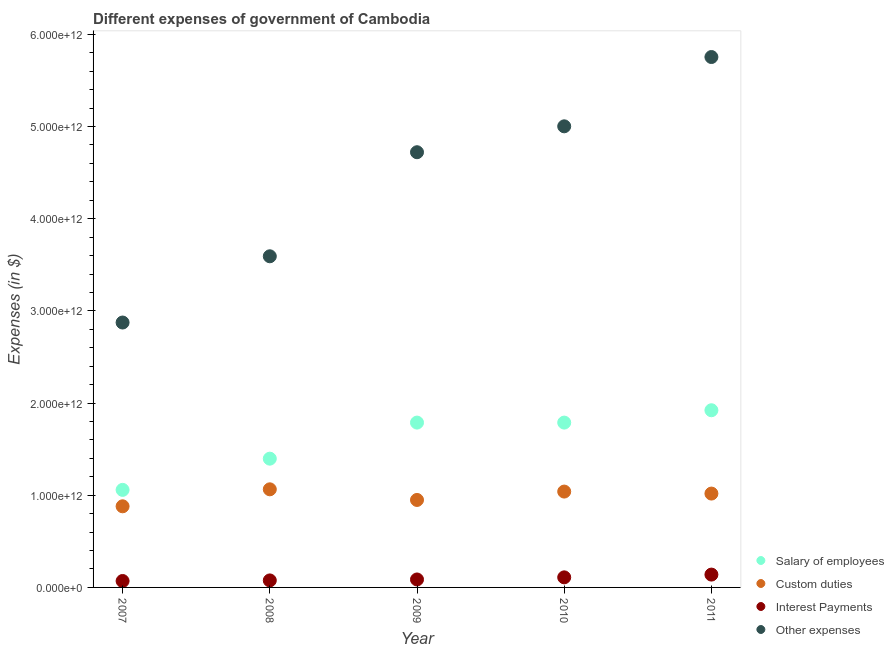How many different coloured dotlines are there?
Your answer should be compact. 4. Is the number of dotlines equal to the number of legend labels?
Keep it short and to the point. Yes. What is the amount spent on interest payments in 2011?
Your answer should be very brief. 1.39e+11. Across all years, what is the maximum amount spent on other expenses?
Your answer should be compact. 5.75e+12. Across all years, what is the minimum amount spent on other expenses?
Your answer should be very brief. 2.87e+12. In which year was the amount spent on salary of employees minimum?
Ensure brevity in your answer.  2007. What is the total amount spent on custom duties in the graph?
Your answer should be compact. 4.95e+12. What is the difference between the amount spent on interest payments in 2009 and that in 2010?
Provide a short and direct response. -2.30e+1. What is the difference between the amount spent on interest payments in 2011 and the amount spent on salary of employees in 2009?
Offer a terse response. -1.65e+12. What is the average amount spent on salary of employees per year?
Keep it short and to the point. 1.59e+12. In the year 2009, what is the difference between the amount spent on other expenses and amount spent on custom duties?
Offer a very short reply. 3.77e+12. In how many years, is the amount spent on custom duties greater than 5200000000000 $?
Offer a terse response. 0. What is the ratio of the amount spent on interest payments in 2007 to that in 2008?
Ensure brevity in your answer.  0.92. Is the amount spent on interest payments in 2007 less than that in 2011?
Keep it short and to the point. Yes. Is the difference between the amount spent on salary of employees in 2008 and 2009 greater than the difference between the amount spent on custom duties in 2008 and 2009?
Make the answer very short. No. What is the difference between the highest and the second highest amount spent on other expenses?
Your response must be concise. 7.52e+11. What is the difference between the highest and the lowest amount spent on interest payments?
Provide a succinct answer. 6.95e+1. In how many years, is the amount spent on other expenses greater than the average amount spent on other expenses taken over all years?
Your answer should be very brief. 3. Is the sum of the amount spent on salary of employees in 2007 and 2011 greater than the maximum amount spent on custom duties across all years?
Make the answer very short. Yes. Is it the case that in every year, the sum of the amount spent on salary of employees and amount spent on other expenses is greater than the sum of amount spent on custom duties and amount spent on interest payments?
Offer a terse response. Yes. Does the amount spent on other expenses monotonically increase over the years?
Your response must be concise. Yes. Is the amount spent on salary of employees strictly greater than the amount spent on other expenses over the years?
Make the answer very short. No. Is the amount spent on other expenses strictly less than the amount spent on salary of employees over the years?
Give a very brief answer. No. How many dotlines are there?
Give a very brief answer. 4. How many years are there in the graph?
Provide a short and direct response. 5. What is the difference between two consecutive major ticks on the Y-axis?
Your response must be concise. 1.00e+12. Are the values on the major ticks of Y-axis written in scientific E-notation?
Keep it short and to the point. Yes. Does the graph contain any zero values?
Make the answer very short. No. Where does the legend appear in the graph?
Your response must be concise. Bottom right. How many legend labels are there?
Give a very brief answer. 4. How are the legend labels stacked?
Your response must be concise. Vertical. What is the title of the graph?
Keep it short and to the point. Different expenses of government of Cambodia. Does "Manufacturing" appear as one of the legend labels in the graph?
Provide a short and direct response. No. What is the label or title of the X-axis?
Offer a very short reply. Year. What is the label or title of the Y-axis?
Offer a very short reply. Expenses (in $). What is the Expenses (in $) in Salary of employees in 2007?
Your answer should be compact. 1.06e+12. What is the Expenses (in $) of Custom duties in 2007?
Provide a succinct answer. 8.80e+11. What is the Expenses (in $) in Interest Payments in 2007?
Keep it short and to the point. 6.97e+1. What is the Expenses (in $) of Other expenses in 2007?
Ensure brevity in your answer.  2.87e+12. What is the Expenses (in $) of Salary of employees in 2008?
Give a very brief answer. 1.40e+12. What is the Expenses (in $) of Custom duties in 2008?
Ensure brevity in your answer.  1.06e+12. What is the Expenses (in $) in Interest Payments in 2008?
Offer a terse response. 7.61e+1. What is the Expenses (in $) in Other expenses in 2008?
Provide a succinct answer. 3.59e+12. What is the Expenses (in $) of Salary of employees in 2009?
Make the answer very short. 1.79e+12. What is the Expenses (in $) in Custom duties in 2009?
Your answer should be very brief. 9.49e+11. What is the Expenses (in $) of Interest Payments in 2009?
Your answer should be very brief. 8.63e+1. What is the Expenses (in $) of Other expenses in 2009?
Your answer should be compact. 4.72e+12. What is the Expenses (in $) of Salary of employees in 2010?
Provide a succinct answer. 1.79e+12. What is the Expenses (in $) in Custom duties in 2010?
Your response must be concise. 1.04e+12. What is the Expenses (in $) in Interest Payments in 2010?
Offer a terse response. 1.09e+11. What is the Expenses (in $) in Other expenses in 2010?
Provide a short and direct response. 5.00e+12. What is the Expenses (in $) in Salary of employees in 2011?
Offer a terse response. 1.92e+12. What is the Expenses (in $) in Custom duties in 2011?
Provide a succinct answer. 1.02e+12. What is the Expenses (in $) of Interest Payments in 2011?
Your answer should be very brief. 1.39e+11. What is the Expenses (in $) in Other expenses in 2011?
Offer a terse response. 5.75e+12. Across all years, what is the maximum Expenses (in $) in Salary of employees?
Offer a very short reply. 1.92e+12. Across all years, what is the maximum Expenses (in $) in Custom duties?
Your answer should be very brief. 1.06e+12. Across all years, what is the maximum Expenses (in $) in Interest Payments?
Offer a terse response. 1.39e+11. Across all years, what is the maximum Expenses (in $) of Other expenses?
Your answer should be very brief. 5.75e+12. Across all years, what is the minimum Expenses (in $) of Salary of employees?
Make the answer very short. 1.06e+12. Across all years, what is the minimum Expenses (in $) of Custom duties?
Give a very brief answer. 8.80e+11. Across all years, what is the minimum Expenses (in $) of Interest Payments?
Your answer should be compact. 6.97e+1. Across all years, what is the minimum Expenses (in $) in Other expenses?
Your answer should be very brief. 2.87e+12. What is the total Expenses (in $) in Salary of employees in the graph?
Your answer should be very brief. 7.95e+12. What is the total Expenses (in $) of Custom duties in the graph?
Keep it short and to the point. 4.95e+12. What is the total Expenses (in $) of Interest Payments in the graph?
Provide a succinct answer. 4.81e+11. What is the total Expenses (in $) in Other expenses in the graph?
Keep it short and to the point. 2.19e+13. What is the difference between the Expenses (in $) in Salary of employees in 2007 and that in 2008?
Provide a short and direct response. -3.39e+11. What is the difference between the Expenses (in $) of Custom duties in 2007 and that in 2008?
Provide a succinct answer. -1.84e+11. What is the difference between the Expenses (in $) of Interest Payments in 2007 and that in 2008?
Your response must be concise. -6.34e+09. What is the difference between the Expenses (in $) of Other expenses in 2007 and that in 2008?
Ensure brevity in your answer.  -7.19e+11. What is the difference between the Expenses (in $) in Salary of employees in 2007 and that in 2009?
Your answer should be very brief. -7.30e+11. What is the difference between the Expenses (in $) of Custom duties in 2007 and that in 2009?
Offer a very short reply. -6.90e+1. What is the difference between the Expenses (in $) of Interest Payments in 2007 and that in 2009?
Offer a very short reply. -1.66e+1. What is the difference between the Expenses (in $) in Other expenses in 2007 and that in 2009?
Give a very brief answer. -1.85e+12. What is the difference between the Expenses (in $) of Salary of employees in 2007 and that in 2010?
Offer a terse response. -7.30e+11. What is the difference between the Expenses (in $) of Custom duties in 2007 and that in 2010?
Make the answer very short. -1.60e+11. What is the difference between the Expenses (in $) in Interest Payments in 2007 and that in 2010?
Offer a very short reply. -3.96e+1. What is the difference between the Expenses (in $) in Other expenses in 2007 and that in 2010?
Your answer should be very brief. -2.13e+12. What is the difference between the Expenses (in $) in Salary of employees in 2007 and that in 2011?
Give a very brief answer. -8.64e+11. What is the difference between the Expenses (in $) of Custom duties in 2007 and that in 2011?
Keep it short and to the point. -1.38e+11. What is the difference between the Expenses (in $) of Interest Payments in 2007 and that in 2011?
Your answer should be very brief. -6.95e+1. What is the difference between the Expenses (in $) of Other expenses in 2007 and that in 2011?
Make the answer very short. -2.88e+12. What is the difference between the Expenses (in $) in Salary of employees in 2008 and that in 2009?
Keep it short and to the point. -3.91e+11. What is the difference between the Expenses (in $) of Custom duties in 2008 and that in 2009?
Provide a short and direct response. 1.15e+11. What is the difference between the Expenses (in $) in Interest Payments in 2008 and that in 2009?
Your answer should be compact. -1.02e+1. What is the difference between the Expenses (in $) in Other expenses in 2008 and that in 2009?
Provide a succinct answer. -1.13e+12. What is the difference between the Expenses (in $) in Salary of employees in 2008 and that in 2010?
Ensure brevity in your answer.  -3.91e+11. What is the difference between the Expenses (in $) of Custom duties in 2008 and that in 2010?
Ensure brevity in your answer.  2.45e+1. What is the difference between the Expenses (in $) of Interest Payments in 2008 and that in 2010?
Give a very brief answer. -3.32e+1. What is the difference between the Expenses (in $) of Other expenses in 2008 and that in 2010?
Give a very brief answer. -1.41e+12. What is the difference between the Expenses (in $) in Salary of employees in 2008 and that in 2011?
Ensure brevity in your answer.  -5.25e+11. What is the difference between the Expenses (in $) of Custom duties in 2008 and that in 2011?
Make the answer very short. 4.62e+1. What is the difference between the Expenses (in $) of Interest Payments in 2008 and that in 2011?
Give a very brief answer. -6.32e+1. What is the difference between the Expenses (in $) in Other expenses in 2008 and that in 2011?
Offer a very short reply. -2.16e+12. What is the difference between the Expenses (in $) in Salary of employees in 2009 and that in 2010?
Provide a succinct answer. 6.24e+06. What is the difference between the Expenses (in $) in Custom duties in 2009 and that in 2010?
Your answer should be compact. -9.09e+1. What is the difference between the Expenses (in $) of Interest Payments in 2009 and that in 2010?
Your answer should be very brief. -2.30e+1. What is the difference between the Expenses (in $) of Other expenses in 2009 and that in 2010?
Provide a short and direct response. -2.81e+11. What is the difference between the Expenses (in $) in Salary of employees in 2009 and that in 2011?
Make the answer very short. -1.34e+11. What is the difference between the Expenses (in $) in Custom duties in 2009 and that in 2011?
Ensure brevity in your answer.  -6.92e+1. What is the difference between the Expenses (in $) of Interest Payments in 2009 and that in 2011?
Give a very brief answer. -5.29e+1. What is the difference between the Expenses (in $) in Other expenses in 2009 and that in 2011?
Keep it short and to the point. -1.03e+12. What is the difference between the Expenses (in $) in Salary of employees in 2010 and that in 2011?
Your answer should be compact. -1.34e+11. What is the difference between the Expenses (in $) in Custom duties in 2010 and that in 2011?
Your answer should be compact. 2.17e+1. What is the difference between the Expenses (in $) in Interest Payments in 2010 and that in 2011?
Ensure brevity in your answer.  -2.99e+1. What is the difference between the Expenses (in $) of Other expenses in 2010 and that in 2011?
Make the answer very short. -7.52e+11. What is the difference between the Expenses (in $) in Salary of employees in 2007 and the Expenses (in $) in Custom duties in 2008?
Offer a terse response. -6.22e+09. What is the difference between the Expenses (in $) of Salary of employees in 2007 and the Expenses (in $) of Interest Payments in 2008?
Make the answer very short. 9.82e+11. What is the difference between the Expenses (in $) in Salary of employees in 2007 and the Expenses (in $) in Other expenses in 2008?
Ensure brevity in your answer.  -2.53e+12. What is the difference between the Expenses (in $) of Custom duties in 2007 and the Expenses (in $) of Interest Payments in 2008?
Keep it short and to the point. 8.04e+11. What is the difference between the Expenses (in $) in Custom duties in 2007 and the Expenses (in $) in Other expenses in 2008?
Your answer should be very brief. -2.71e+12. What is the difference between the Expenses (in $) of Interest Payments in 2007 and the Expenses (in $) of Other expenses in 2008?
Provide a short and direct response. -3.52e+12. What is the difference between the Expenses (in $) in Salary of employees in 2007 and the Expenses (in $) in Custom duties in 2009?
Provide a short and direct response. 1.09e+11. What is the difference between the Expenses (in $) in Salary of employees in 2007 and the Expenses (in $) in Interest Payments in 2009?
Your response must be concise. 9.72e+11. What is the difference between the Expenses (in $) of Salary of employees in 2007 and the Expenses (in $) of Other expenses in 2009?
Your answer should be very brief. -3.66e+12. What is the difference between the Expenses (in $) in Custom duties in 2007 and the Expenses (in $) in Interest Payments in 2009?
Provide a short and direct response. 7.94e+11. What is the difference between the Expenses (in $) of Custom duties in 2007 and the Expenses (in $) of Other expenses in 2009?
Provide a short and direct response. -3.84e+12. What is the difference between the Expenses (in $) in Interest Payments in 2007 and the Expenses (in $) in Other expenses in 2009?
Your answer should be very brief. -4.65e+12. What is the difference between the Expenses (in $) in Salary of employees in 2007 and the Expenses (in $) in Custom duties in 2010?
Provide a succinct answer. 1.83e+1. What is the difference between the Expenses (in $) of Salary of employees in 2007 and the Expenses (in $) of Interest Payments in 2010?
Make the answer very short. 9.49e+11. What is the difference between the Expenses (in $) in Salary of employees in 2007 and the Expenses (in $) in Other expenses in 2010?
Your answer should be compact. -3.94e+12. What is the difference between the Expenses (in $) of Custom duties in 2007 and the Expenses (in $) of Interest Payments in 2010?
Offer a terse response. 7.71e+11. What is the difference between the Expenses (in $) in Custom duties in 2007 and the Expenses (in $) in Other expenses in 2010?
Offer a terse response. -4.12e+12. What is the difference between the Expenses (in $) of Interest Payments in 2007 and the Expenses (in $) of Other expenses in 2010?
Ensure brevity in your answer.  -4.93e+12. What is the difference between the Expenses (in $) of Salary of employees in 2007 and the Expenses (in $) of Custom duties in 2011?
Ensure brevity in your answer.  4.00e+1. What is the difference between the Expenses (in $) of Salary of employees in 2007 and the Expenses (in $) of Interest Payments in 2011?
Keep it short and to the point. 9.19e+11. What is the difference between the Expenses (in $) in Salary of employees in 2007 and the Expenses (in $) in Other expenses in 2011?
Offer a terse response. -4.70e+12. What is the difference between the Expenses (in $) of Custom duties in 2007 and the Expenses (in $) of Interest Payments in 2011?
Ensure brevity in your answer.  7.41e+11. What is the difference between the Expenses (in $) of Custom duties in 2007 and the Expenses (in $) of Other expenses in 2011?
Provide a short and direct response. -4.87e+12. What is the difference between the Expenses (in $) of Interest Payments in 2007 and the Expenses (in $) of Other expenses in 2011?
Provide a succinct answer. -5.68e+12. What is the difference between the Expenses (in $) of Salary of employees in 2008 and the Expenses (in $) of Custom duties in 2009?
Your response must be concise. 4.48e+11. What is the difference between the Expenses (in $) of Salary of employees in 2008 and the Expenses (in $) of Interest Payments in 2009?
Your answer should be compact. 1.31e+12. What is the difference between the Expenses (in $) in Salary of employees in 2008 and the Expenses (in $) in Other expenses in 2009?
Your response must be concise. -3.32e+12. What is the difference between the Expenses (in $) of Custom duties in 2008 and the Expenses (in $) of Interest Payments in 2009?
Your response must be concise. 9.78e+11. What is the difference between the Expenses (in $) of Custom duties in 2008 and the Expenses (in $) of Other expenses in 2009?
Ensure brevity in your answer.  -3.66e+12. What is the difference between the Expenses (in $) in Interest Payments in 2008 and the Expenses (in $) in Other expenses in 2009?
Offer a very short reply. -4.65e+12. What is the difference between the Expenses (in $) in Salary of employees in 2008 and the Expenses (in $) in Custom duties in 2010?
Keep it short and to the point. 3.57e+11. What is the difference between the Expenses (in $) in Salary of employees in 2008 and the Expenses (in $) in Interest Payments in 2010?
Offer a very short reply. 1.29e+12. What is the difference between the Expenses (in $) in Salary of employees in 2008 and the Expenses (in $) in Other expenses in 2010?
Provide a short and direct response. -3.61e+12. What is the difference between the Expenses (in $) in Custom duties in 2008 and the Expenses (in $) in Interest Payments in 2010?
Make the answer very short. 9.55e+11. What is the difference between the Expenses (in $) in Custom duties in 2008 and the Expenses (in $) in Other expenses in 2010?
Your response must be concise. -3.94e+12. What is the difference between the Expenses (in $) in Interest Payments in 2008 and the Expenses (in $) in Other expenses in 2010?
Provide a short and direct response. -4.93e+12. What is the difference between the Expenses (in $) of Salary of employees in 2008 and the Expenses (in $) of Custom duties in 2011?
Provide a succinct answer. 3.79e+11. What is the difference between the Expenses (in $) in Salary of employees in 2008 and the Expenses (in $) in Interest Payments in 2011?
Your answer should be compact. 1.26e+12. What is the difference between the Expenses (in $) in Salary of employees in 2008 and the Expenses (in $) in Other expenses in 2011?
Offer a terse response. -4.36e+12. What is the difference between the Expenses (in $) of Custom duties in 2008 and the Expenses (in $) of Interest Payments in 2011?
Offer a terse response. 9.25e+11. What is the difference between the Expenses (in $) of Custom duties in 2008 and the Expenses (in $) of Other expenses in 2011?
Provide a succinct answer. -4.69e+12. What is the difference between the Expenses (in $) of Interest Payments in 2008 and the Expenses (in $) of Other expenses in 2011?
Provide a succinct answer. -5.68e+12. What is the difference between the Expenses (in $) in Salary of employees in 2009 and the Expenses (in $) in Custom duties in 2010?
Your answer should be very brief. 7.48e+11. What is the difference between the Expenses (in $) of Salary of employees in 2009 and the Expenses (in $) of Interest Payments in 2010?
Give a very brief answer. 1.68e+12. What is the difference between the Expenses (in $) in Salary of employees in 2009 and the Expenses (in $) in Other expenses in 2010?
Give a very brief answer. -3.21e+12. What is the difference between the Expenses (in $) in Custom duties in 2009 and the Expenses (in $) in Interest Payments in 2010?
Keep it short and to the point. 8.40e+11. What is the difference between the Expenses (in $) in Custom duties in 2009 and the Expenses (in $) in Other expenses in 2010?
Ensure brevity in your answer.  -4.05e+12. What is the difference between the Expenses (in $) in Interest Payments in 2009 and the Expenses (in $) in Other expenses in 2010?
Make the answer very short. -4.92e+12. What is the difference between the Expenses (in $) in Salary of employees in 2009 and the Expenses (in $) in Custom duties in 2011?
Offer a terse response. 7.70e+11. What is the difference between the Expenses (in $) in Salary of employees in 2009 and the Expenses (in $) in Interest Payments in 2011?
Offer a terse response. 1.65e+12. What is the difference between the Expenses (in $) of Salary of employees in 2009 and the Expenses (in $) of Other expenses in 2011?
Make the answer very short. -3.97e+12. What is the difference between the Expenses (in $) of Custom duties in 2009 and the Expenses (in $) of Interest Payments in 2011?
Offer a very short reply. 8.10e+11. What is the difference between the Expenses (in $) of Custom duties in 2009 and the Expenses (in $) of Other expenses in 2011?
Your response must be concise. -4.81e+12. What is the difference between the Expenses (in $) of Interest Payments in 2009 and the Expenses (in $) of Other expenses in 2011?
Your response must be concise. -5.67e+12. What is the difference between the Expenses (in $) in Salary of employees in 2010 and the Expenses (in $) in Custom duties in 2011?
Offer a very short reply. 7.70e+11. What is the difference between the Expenses (in $) in Salary of employees in 2010 and the Expenses (in $) in Interest Payments in 2011?
Provide a succinct answer. 1.65e+12. What is the difference between the Expenses (in $) in Salary of employees in 2010 and the Expenses (in $) in Other expenses in 2011?
Provide a succinct answer. -3.97e+12. What is the difference between the Expenses (in $) in Custom duties in 2010 and the Expenses (in $) in Interest Payments in 2011?
Ensure brevity in your answer.  9.01e+11. What is the difference between the Expenses (in $) in Custom duties in 2010 and the Expenses (in $) in Other expenses in 2011?
Your response must be concise. -4.71e+12. What is the difference between the Expenses (in $) in Interest Payments in 2010 and the Expenses (in $) in Other expenses in 2011?
Provide a short and direct response. -5.65e+12. What is the average Expenses (in $) of Salary of employees per year?
Your answer should be very brief. 1.59e+12. What is the average Expenses (in $) in Custom duties per year?
Provide a short and direct response. 9.90e+11. What is the average Expenses (in $) of Interest Payments per year?
Your response must be concise. 9.61e+1. What is the average Expenses (in $) in Other expenses per year?
Ensure brevity in your answer.  4.39e+12. In the year 2007, what is the difference between the Expenses (in $) in Salary of employees and Expenses (in $) in Custom duties?
Your answer should be compact. 1.78e+11. In the year 2007, what is the difference between the Expenses (in $) in Salary of employees and Expenses (in $) in Interest Payments?
Keep it short and to the point. 9.88e+11. In the year 2007, what is the difference between the Expenses (in $) in Salary of employees and Expenses (in $) in Other expenses?
Your answer should be compact. -1.82e+12. In the year 2007, what is the difference between the Expenses (in $) of Custom duties and Expenses (in $) of Interest Payments?
Give a very brief answer. 8.10e+11. In the year 2007, what is the difference between the Expenses (in $) of Custom duties and Expenses (in $) of Other expenses?
Ensure brevity in your answer.  -1.99e+12. In the year 2007, what is the difference between the Expenses (in $) in Interest Payments and Expenses (in $) in Other expenses?
Your answer should be compact. -2.80e+12. In the year 2008, what is the difference between the Expenses (in $) in Salary of employees and Expenses (in $) in Custom duties?
Your answer should be very brief. 3.32e+11. In the year 2008, what is the difference between the Expenses (in $) in Salary of employees and Expenses (in $) in Interest Payments?
Your answer should be very brief. 1.32e+12. In the year 2008, what is the difference between the Expenses (in $) of Salary of employees and Expenses (in $) of Other expenses?
Offer a very short reply. -2.20e+12. In the year 2008, what is the difference between the Expenses (in $) in Custom duties and Expenses (in $) in Interest Payments?
Your answer should be very brief. 9.88e+11. In the year 2008, what is the difference between the Expenses (in $) of Custom duties and Expenses (in $) of Other expenses?
Your answer should be very brief. -2.53e+12. In the year 2008, what is the difference between the Expenses (in $) in Interest Payments and Expenses (in $) in Other expenses?
Offer a terse response. -3.52e+12. In the year 2009, what is the difference between the Expenses (in $) of Salary of employees and Expenses (in $) of Custom duties?
Give a very brief answer. 8.39e+11. In the year 2009, what is the difference between the Expenses (in $) in Salary of employees and Expenses (in $) in Interest Payments?
Offer a very short reply. 1.70e+12. In the year 2009, what is the difference between the Expenses (in $) of Salary of employees and Expenses (in $) of Other expenses?
Your answer should be compact. -2.93e+12. In the year 2009, what is the difference between the Expenses (in $) in Custom duties and Expenses (in $) in Interest Payments?
Your answer should be compact. 8.63e+11. In the year 2009, what is the difference between the Expenses (in $) of Custom duties and Expenses (in $) of Other expenses?
Ensure brevity in your answer.  -3.77e+12. In the year 2009, what is the difference between the Expenses (in $) in Interest Payments and Expenses (in $) in Other expenses?
Your answer should be compact. -4.64e+12. In the year 2010, what is the difference between the Expenses (in $) in Salary of employees and Expenses (in $) in Custom duties?
Your answer should be compact. 7.48e+11. In the year 2010, what is the difference between the Expenses (in $) in Salary of employees and Expenses (in $) in Interest Payments?
Your answer should be very brief. 1.68e+12. In the year 2010, what is the difference between the Expenses (in $) of Salary of employees and Expenses (in $) of Other expenses?
Your answer should be compact. -3.21e+12. In the year 2010, what is the difference between the Expenses (in $) of Custom duties and Expenses (in $) of Interest Payments?
Your answer should be very brief. 9.31e+11. In the year 2010, what is the difference between the Expenses (in $) in Custom duties and Expenses (in $) in Other expenses?
Your answer should be very brief. -3.96e+12. In the year 2010, what is the difference between the Expenses (in $) of Interest Payments and Expenses (in $) of Other expenses?
Give a very brief answer. -4.89e+12. In the year 2011, what is the difference between the Expenses (in $) in Salary of employees and Expenses (in $) in Custom duties?
Your response must be concise. 9.04e+11. In the year 2011, what is the difference between the Expenses (in $) in Salary of employees and Expenses (in $) in Interest Payments?
Keep it short and to the point. 1.78e+12. In the year 2011, what is the difference between the Expenses (in $) in Salary of employees and Expenses (in $) in Other expenses?
Your answer should be very brief. -3.83e+12. In the year 2011, what is the difference between the Expenses (in $) in Custom duties and Expenses (in $) in Interest Payments?
Keep it short and to the point. 8.79e+11. In the year 2011, what is the difference between the Expenses (in $) of Custom duties and Expenses (in $) of Other expenses?
Your answer should be very brief. -4.74e+12. In the year 2011, what is the difference between the Expenses (in $) of Interest Payments and Expenses (in $) of Other expenses?
Your response must be concise. -5.62e+12. What is the ratio of the Expenses (in $) of Salary of employees in 2007 to that in 2008?
Offer a very short reply. 0.76. What is the ratio of the Expenses (in $) of Custom duties in 2007 to that in 2008?
Give a very brief answer. 0.83. What is the ratio of the Expenses (in $) of Interest Payments in 2007 to that in 2008?
Provide a succinct answer. 0.92. What is the ratio of the Expenses (in $) in Other expenses in 2007 to that in 2008?
Offer a terse response. 0.8. What is the ratio of the Expenses (in $) in Salary of employees in 2007 to that in 2009?
Keep it short and to the point. 0.59. What is the ratio of the Expenses (in $) of Custom duties in 2007 to that in 2009?
Offer a very short reply. 0.93. What is the ratio of the Expenses (in $) of Interest Payments in 2007 to that in 2009?
Make the answer very short. 0.81. What is the ratio of the Expenses (in $) in Other expenses in 2007 to that in 2009?
Ensure brevity in your answer.  0.61. What is the ratio of the Expenses (in $) in Salary of employees in 2007 to that in 2010?
Ensure brevity in your answer.  0.59. What is the ratio of the Expenses (in $) in Custom duties in 2007 to that in 2010?
Give a very brief answer. 0.85. What is the ratio of the Expenses (in $) in Interest Payments in 2007 to that in 2010?
Your answer should be very brief. 0.64. What is the ratio of the Expenses (in $) in Other expenses in 2007 to that in 2010?
Provide a succinct answer. 0.57. What is the ratio of the Expenses (in $) of Salary of employees in 2007 to that in 2011?
Your answer should be very brief. 0.55. What is the ratio of the Expenses (in $) of Custom duties in 2007 to that in 2011?
Your response must be concise. 0.86. What is the ratio of the Expenses (in $) of Interest Payments in 2007 to that in 2011?
Your response must be concise. 0.5. What is the ratio of the Expenses (in $) in Other expenses in 2007 to that in 2011?
Your answer should be compact. 0.5. What is the ratio of the Expenses (in $) of Salary of employees in 2008 to that in 2009?
Your answer should be very brief. 0.78. What is the ratio of the Expenses (in $) of Custom duties in 2008 to that in 2009?
Ensure brevity in your answer.  1.12. What is the ratio of the Expenses (in $) in Interest Payments in 2008 to that in 2009?
Ensure brevity in your answer.  0.88. What is the ratio of the Expenses (in $) in Other expenses in 2008 to that in 2009?
Provide a succinct answer. 0.76. What is the ratio of the Expenses (in $) of Salary of employees in 2008 to that in 2010?
Make the answer very short. 0.78. What is the ratio of the Expenses (in $) of Custom duties in 2008 to that in 2010?
Your answer should be compact. 1.02. What is the ratio of the Expenses (in $) of Interest Payments in 2008 to that in 2010?
Provide a succinct answer. 0.7. What is the ratio of the Expenses (in $) in Other expenses in 2008 to that in 2010?
Ensure brevity in your answer.  0.72. What is the ratio of the Expenses (in $) of Salary of employees in 2008 to that in 2011?
Make the answer very short. 0.73. What is the ratio of the Expenses (in $) of Custom duties in 2008 to that in 2011?
Ensure brevity in your answer.  1.05. What is the ratio of the Expenses (in $) in Interest Payments in 2008 to that in 2011?
Ensure brevity in your answer.  0.55. What is the ratio of the Expenses (in $) of Other expenses in 2008 to that in 2011?
Make the answer very short. 0.62. What is the ratio of the Expenses (in $) of Custom duties in 2009 to that in 2010?
Offer a terse response. 0.91. What is the ratio of the Expenses (in $) of Interest Payments in 2009 to that in 2010?
Give a very brief answer. 0.79. What is the ratio of the Expenses (in $) of Other expenses in 2009 to that in 2010?
Offer a very short reply. 0.94. What is the ratio of the Expenses (in $) in Salary of employees in 2009 to that in 2011?
Make the answer very short. 0.93. What is the ratio of the Expenses (in $) in Custom duties in 2009 to that in 2011?
Keep it short and to the point. 0.93. What is the ratio of the Expenses (in $) in Interest Payments in 2009 to that in 2011?
Provide a succinct answer. 0.62. What is the ratio of the Expenses (in $) in Other expenses in 2009 to that in 2011?
Your answer should be very brief. 0.82. What is the ratio of the Expenses (in $) in Salary of employees in 2010 to that in 2011?
Your response must be concise. 0.93. What is the ratio of the Expenses (in $) in Custom duties in 2010 to that in 2011?
Offer a very short reply. 1.02. What is the ratio of the Expenses (in $) in Interest Payments in 2010 to that in 2011?
Keep it short and to the point. 0.79. What is the ratio of the Expenses (in $) in Other expenses in 2010 to that in 2011?
Offer a very short reply. 0.87. What is the difference between the highest and the second highest Expenses (in $) of Salary of employees?
Provide a succinct answer. 1.34e+11. What is the difference between the highest and the second highest Expenses (in $) of Custom duties?
Keep it short and to the point. 2.45e+1. What is the difference between the highest and the second highest Expenses (in $) in Interest Payments?
Provide a succinct answer. 2.99e+1. What is the difference between the highest and the second highest Expenses (in $) in Other expenses?
Offer a very short reply. 7.52e+11. What is the difference between the highest and the lowest Expenses (in $) in Salary of employees?
Offer a very short reply. 8.64e+11. What is the difference between the highest and the lowest Expenses (in $) of Custom duties?
Provide a short and direct response. 1.84e+11. What is the difference between the highest and the lowest Expenses (in $) in Interest Payments?
Give a very brief answer. 6.95e+1. What is the difference between the highest and the lowest Expenses (in $) of Other expenses?
Your answer should be very brief. 2.88e+12. 